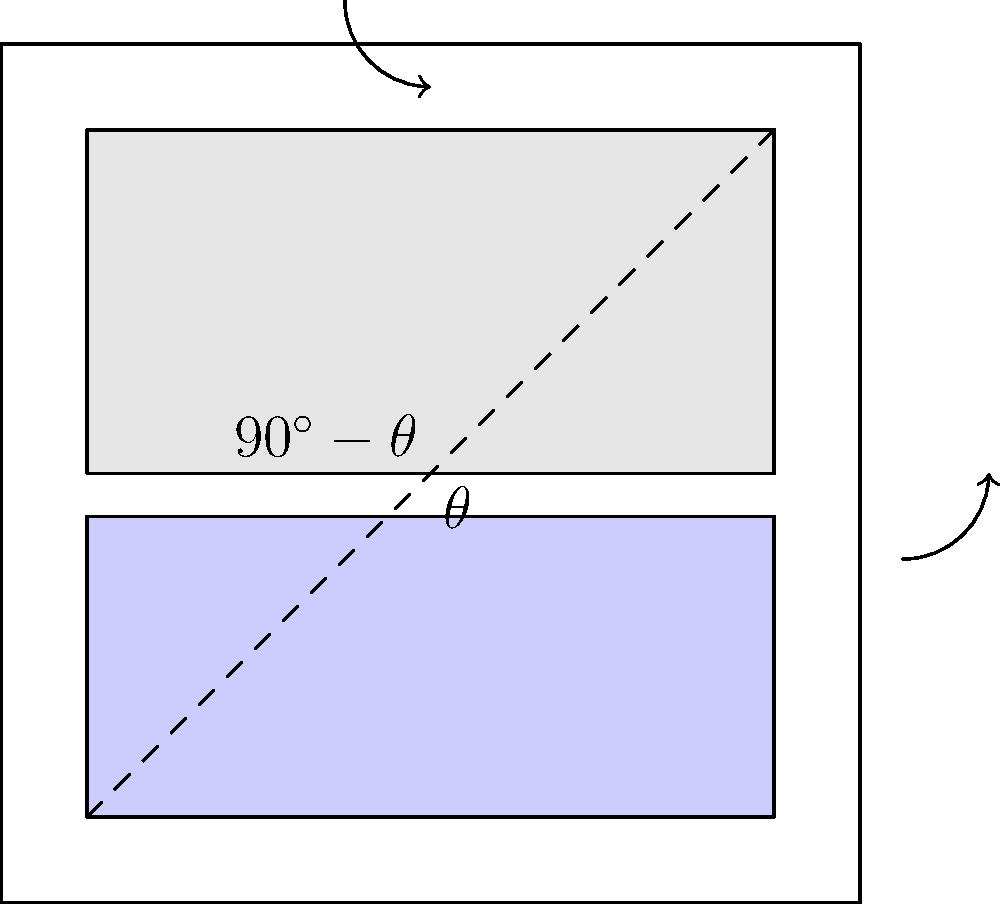In the diagram above, representing a social media advertisement layout, how does the angle $\theta$ between the text and image areas impact user engagement, and what is the optimal value of $\theta$ for maximizing visual appeal and information retention? To answer this question, we need to consider several factors:

1. Visual Flow: The diagonal line creates a natural flow from the top-left to the bottom-right, which follows the typical Western reading pattern.

2. Golden Ratio: The optimal angle $\theta$ is often related to the golden ratio, approximately 1.618. This ratio is aesthetically pleasing and found in nature and art.

3. Eye Movement: The arrows indicate the natural eye movement pattern when viewing the advertisement.

4. Balance: The angle $\theta$ determines the balance between text and image content.

5. Information Processing: The brain processes text and images differently, and their arrangement affects cognitive load.

6. Engagement Metrics: Research in advertising psychology shows that the layout significantly impacts user engagement, measured by metrics like click-through rates and time spent viewing.

7. Optimal Angle: Studies suggest that when $\theta$ is around 60°, it creates a harmonious balance that aligns with the golden ratio (as $\cos 60° \approx 0.5$, which is close to the reciprocal of the golden ratio).

8. Visual Appeal: An angle of 60° creates a dynamic composition that is visually appealing without being too extreme.

9. Information Retention: This layout allows for a natural transition between text and image, potentially improving information retention.

10. Cognitive Processing: The 60° angle facilitates smooth eye movement between text and image, reducing cognitive load and improving overall comprehension.

Given these factors, the optimal value of $\theta$ for maximizing visual appeal and information retention is approximately 60°.
Answer: 60° 